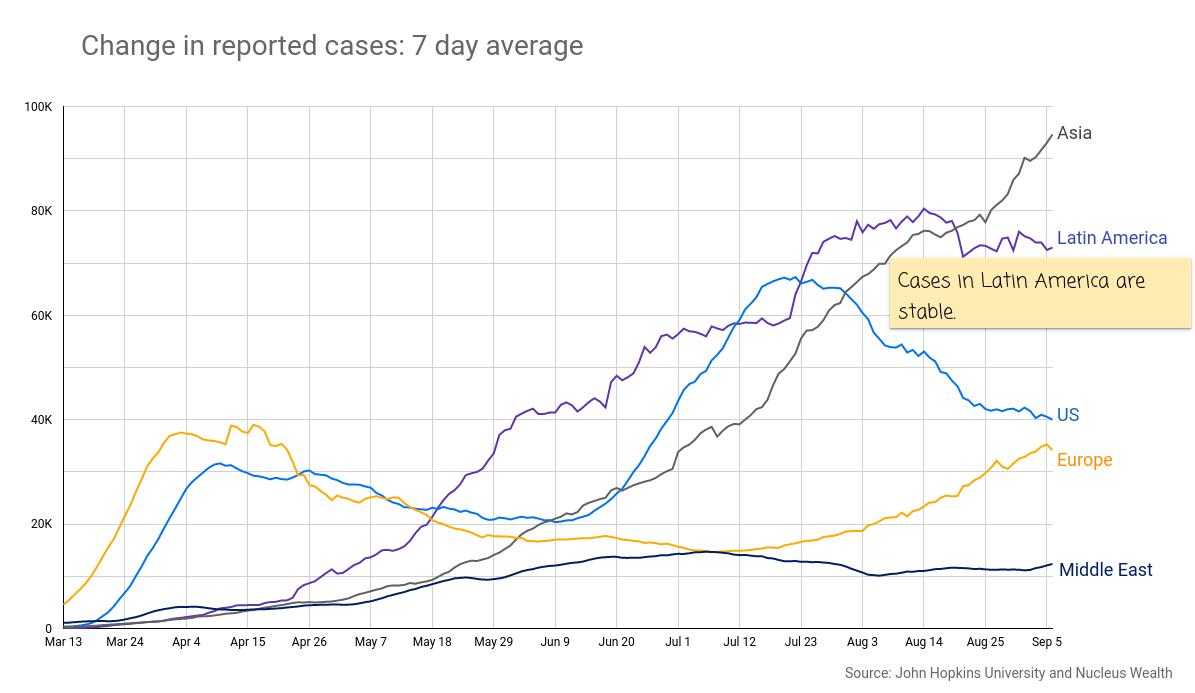Highlight a few significant elements in this photo. Based on the data provided, two regions have reached more than 70,000 cases during the period of August 25 to September 5: Asia and Latin America. On March 13th, Europe had the highest number of COVID-19 cases. There are five regions plotted on the graph. On April 26, there were approximately 30,000 cases reported in the United States. During the period of August 3-August 14, the region with the highest number of cases was Latin America. 